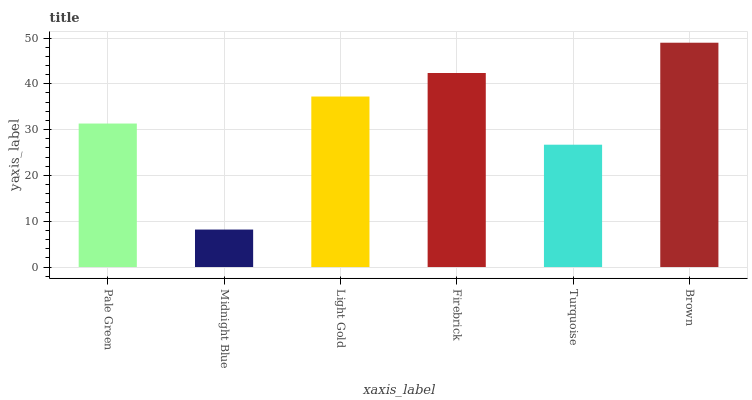Is Midnight Blue the minimum?
Answer yes or no. Yes. Is Brown the maximum?
Answer yes or no. Yes. Is Light Gold the minimum?
Answer yes or no. No. Is Light Gold the maximum?
Answer yes or no. No. Is Light Gold greater than Midnight Blue?
Answer yes or no. Yes. Is Midnight Blue less than Light Gold?
Answer yes or no. Yes. Is Midnight Blue greater than Light Gold?
Answer yes or no. No. Is Light Gold less than Midnight Blue?
Answer yes or no. No. Is Light Gold the high median?
Answer yes or no. Yes. Is Pale Green the low median?
Answer yes or no. Yes. Is Turquoise the high median?
Answer yes or no. No. Is Midnight Blue the low median?
Answer yes or no. No. 